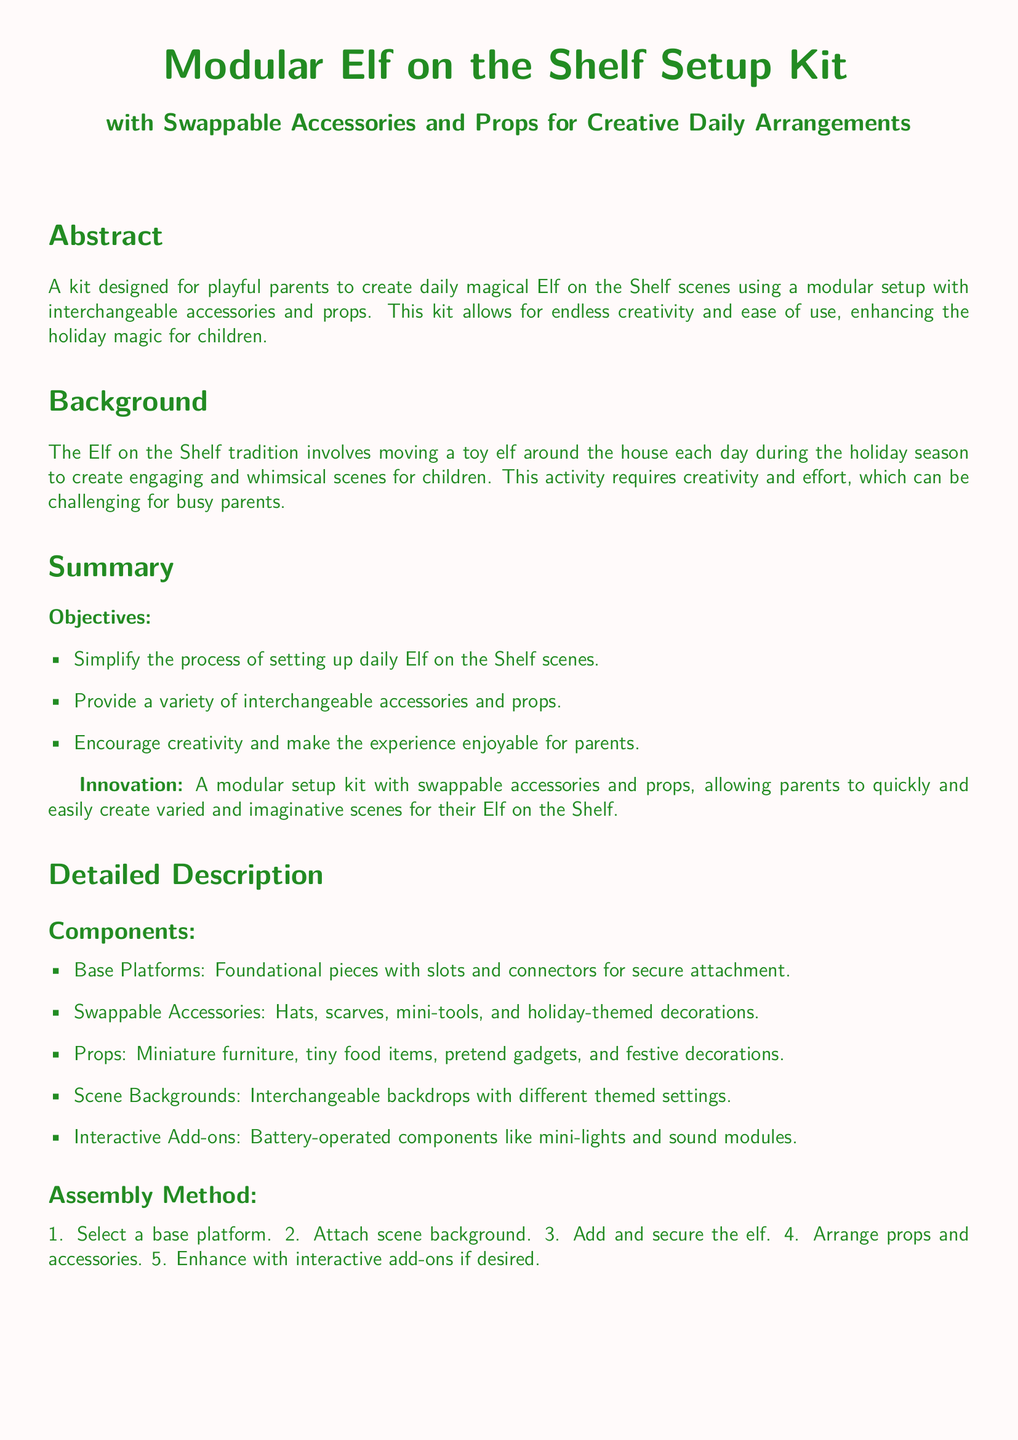What is the title of the patent application? The title is prominently displayed at the top of the document and describes the subject matter of the invention.
Answer: Modular Elf on the Shelf Setup Kit with Swappable Accessories and Props for Creative Daily Arrangements What are the components of the kit? The document lists the components in a section labeled "Components," detailing what is included in the kit.
Answer: Base Platforms, Swappable Accessories, Props, Scene Backgrounds, Interactive Add-ons Who is the inventor? The inventor's name is presented in the footer of the document.
Answer: John Playful-Pater What is the application number? The application number is located in the footer, indicating the unique identifier of the patent application.
Answer: US2023123456A1 What is one objective of the kit? Objectives are outlined in a bullet point list, highlighting the goals of the invention.
Answer: Simplify the process of setting up daily Elf on the Shelf scenes How many claims are there in the document? The number of claims is indicated at the beginning of the "Claims" section.
Answer: Four What feature enhances the scenes created with the setup kit? The document mentions a specific type of accessory that adds interactive qualities to the scenes.
Answer: Battery-operated interactive add-ons What is the filing date of the patent application? The filing date is given in the footer, indicating when the application was submitted.
Answer: 2023-12-01 What is the main benefit of the modular kit for parents? The advantages are summarized in the "Summary" section, emphasizing the experience for parents.
Answer: Encourage creativity and make the experience enjoyable for parents 